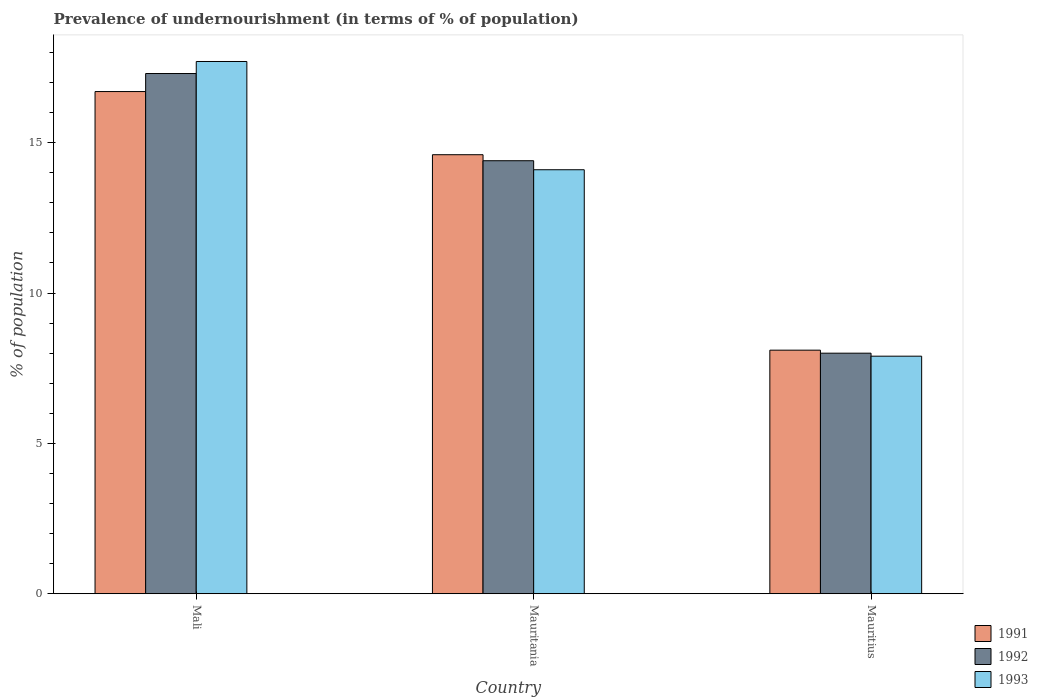Are the number of bars on each tick of the X-axis equal?
Ensure brevity in your answer.  Yes. What is the label of the 1st group of bars from the left?
Provide a succinct answer. Mali. In how many cases, is the number of bars for a given country not equal to the number of legend labels?
Make the answer very short. 0. Across all countries, what is the maximum percentage of undernourished population in 1992?
Keep it short and to the point. 17.3. In which country was the percentage of undernourished population in 1992 maximum?
Your answer should be very brief. Mali. In which country was the percentage of undernourished population in 1993 minimum?
Ensure brevity in your answer.  Mauritius. What is the total percentage of undernourished population in 1991 in the graph?
Offer a very short reply. 39.4. What is the difference between the percentage of undernourished population in 1993 in Mali and that in Mauritius?
Give a very brief answer. 9.8. What is the difference between the percentage of undernourished population in 1992 in Mauritania and the percentage of undernourished population in 1991 in Mauritius?
Make the answer very short. 6.3. What is the average percentage of undernourished population in 1991 per country?
Ensure brevity in your answer.  13.13. What is the difference between the percentage of undernourished population of/in 1993 and percentage of undernourished population of/in 1992 in Mauritania?
Ensure brevity in your answer.  -0.3. In how many countries, is the percentage of undernourished population in 1993 greater than 9 %?
Your answer should be very brief. 2. What is the ratio of the percentage of undernourished population in 1993 in Mali to that in Mauritania?
Keep it short and to the point. 1.26. Is the percentage of undernourished population in 1991 in Mali less than that in Mauritania?
Offer a terse response. No. What is the difference between the highest and the lowest percentage of undernourished population in 1991?
Make the answer very short. 8.6. What does the 1st bar from the left in Mauritania represents?
Make the answer very short. 1991. What does the 2nd bar from the right in Mauritania represents?
Your answer should be very brief. 1992. How many bars are there?
Your answer should be very brief. 9. How many countries are there in the graph?
Ensure brevity in your answer.  3. What is the difference between two consecutive major ticks on the Y-axis?
Make the answer very short. 5. Does the graph contain any zero values?
Your answer should be compact. No. Does the graph contain grids?
Give a very brief answer. No. What is the title of the graph?
Your response must be concise. Prevalence of undernourishment (in terms of % of population). What is the label or title of the X-axis?
Your response must be concise. Country. What is the label or title of the Y-axis?
Ensure brevity in your answer.  % of population. What is the % of population in 1991 in Mali?
Provide a succinct answer. 16.7. What is the % of population in 1992 in Mali?
Your response must be concise. 17.3. What is the % of population in 1993 in Mali?
Your response must be concise. 17.7. What is the % of population of 1991 in Mauritania?
Provide a succinct answer. 14.6. What is the % of population in 1992 in Mauritania?
Provide a short and direct response. 14.4. What is the % of population in 1993 in Mauritania?
Keep it short and to the point. 14.1. Across all countries, what is the maximum % of population in 1991?
Provide a succinct answer. 16.7. What is the total % of population in 1991 in the graph?
Offer a terse response. 39.4. What is the total % of population of 1992 in the graph?
Give a very brief answer. 39.7. What is the total % of population in 1993 in the graph?
Offer a very short reply. 39.7. What is the difference between the % of population of 1993 in Mali and that in Mauritania?
Ensure brevity in your answer.  3.6. What is the difference between the % of population in 1991 in Mali and that in Mauritius?
Provide a short and direct response. 8.6. What is the difference between the % of population of 1991 in Mauritania and that in Mauritius?
Your response must be concise. 6.5. What is the difference between the % of population of 1992 in Mauritania and that in Mauritius?
Give a very brief answer. 6.4. What is the difference between the % of population of 1993 in Mauritania and that in Mauritius?
Ensure brevity in your answer.  6.2. What is the difference between the % of population in 1991 in Mali and the % of population in 1992 in Mauritania?
Keep it short and to the point. 2.3. What is the difference between the % of population in 1992 in Mali and the % of population in 1993 in Mauritania?
Offer a very short reply. 3.2. What is the difference between the % of population in 1991 in Mali and the % of population in 1993 in Mauritius?
Keep it short and to the point. 8.8. What is the difference between the % of population in 1991 in Mauritania and the % of population in 1992 in Mauritius?
Your answer should be compact. 6.6. What is the difference between the % of population in 1992 in Mauritania and the % of population in 1993 in Mauritius?
Offer a terse response. 6.5. What is the average % of population of 1991 per country?
Offer a very short reply. 13.13. What is the average % of population in 1992 per country?
Provide a short and direct response. 13.23. What is the average % of population in 1993 per country?
Provide a short and direct response. 13.23. What is the difference between the % of population in 1991 and % of population in 1993 in Mali?
Give a very brief answer. -1. What is the difference between the % of population in 1992 and % of population in 1993 in Mali?
Your response must be concise. -0.4. What is the difference between the % of population of 1991 and % of population of 1993 in Mauritius?
Your answer should be compact. 0.2. What is the difference between the % of population in 1992 and % of population in 1993 in Mauritius?
Your response must be concise. 0.1. What is the ratio of the % of population of 1991 in Mali to that in Mauritania?
Your response must be concise. 1.14. What is the ratio of the % of population in 1992 in Mali to that in Mauritania?
Your answer should be compact. 1.2. What is the ratio of the % of population of 1993 in Mali to that in Mauritania?
Keep it short and to the point. 1.26. What is the ratio of the % of population of 1991 in Mali to that in Mauritius?
Offer a very short reply. 2.06. What is the ratio of the % of population of 1992 in Mali to that in Mauritius?
Your response must be concise. 2.16. What is the ratio of the % of population in 1993 in Mali to that in Mauritius?
Provide a short and direct response. 2.24. What is the ratio of the % of population of 1991 in Mauritania to that in Mauritius?
Ensure brevity in your answer.  1.8. What is the ratio of the % of population in 1992 in Mauritania to that in Mauritius?
Your answer should be compact. 1.8. What is the ratio of the % of population in 1993 in Mauritania to that in Mauritius?
Offer a very short reply. 1.78. What is the difference between the highest and the second highest % of population of 1991?
Make the answer very short. 2.1. What is the difference between the highest and the second highest % of population in 1993?
Give a very brief answer. 3.6. What is the difference between the highest and the lowest % of population of 1991?
Offer a terse response. 8.6. What is the difference between the highest and the lowest % of population of 1993?
Offer a terse response. 9.8. 